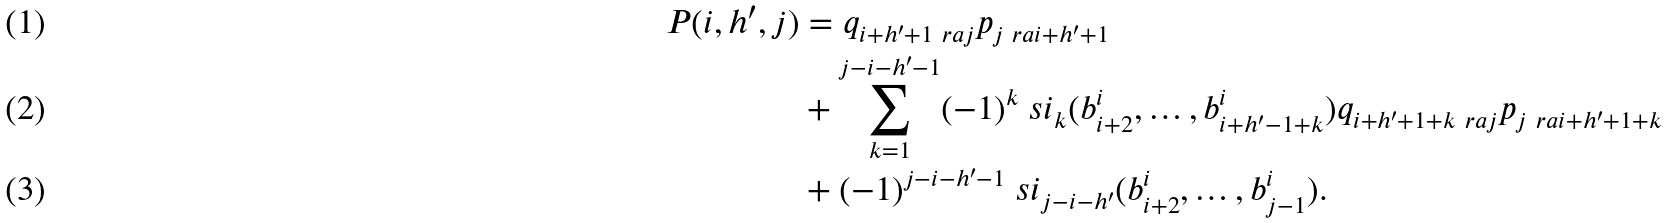<formula> <loc_0><loc_0><loc_500><loc_500>P ( i , h ^ { \prime } , j ) & = q _ { i + h ^ { \prime } + 1 \ r a j } p _ { j \ r a i + h ^ { \prime } + 1 } \\ & + \sum _ { k = 1 } ^ { j - i - h ^ { \prime } - 1 } ( - 1 ) ^ { k } \ s i _ { k } ( b ^ { i } _ { i + 2 } , \dots , b ^ { i } _ { i + h ^ { \prime } - 1 + k } ) q _ { i + h ^ { \prime } + 1 + k \ r a j } p _ { j \ r a i + h ^ { \prime } + 1 + k } \\ & + ( - 1 ) ^ { j - i - h ^ { \prime } - 1 } \ s i _ { j - i - h ^ { \prime } } ( b ^ { i } _ { i + 2 } , \dots , b ^ { i } _ { j - 1 } ) .</formula> 